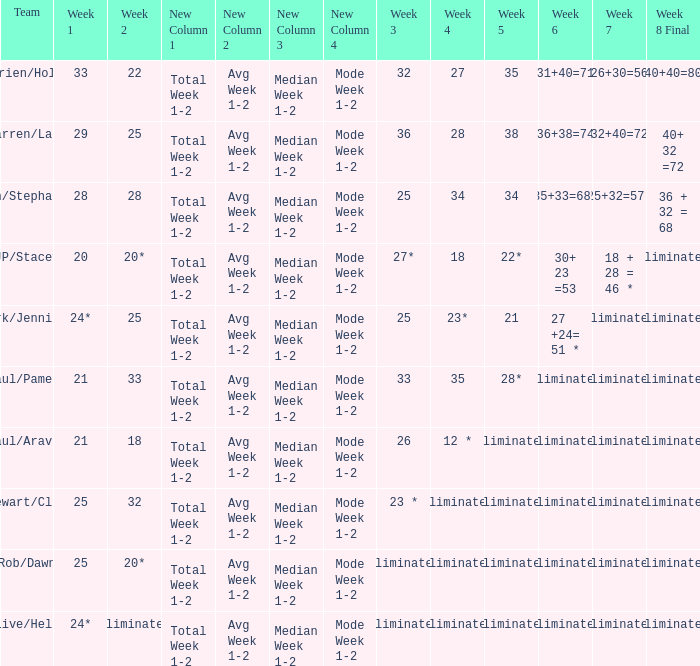Name the week 3 with week 6 of 31+40=71 32.0. 